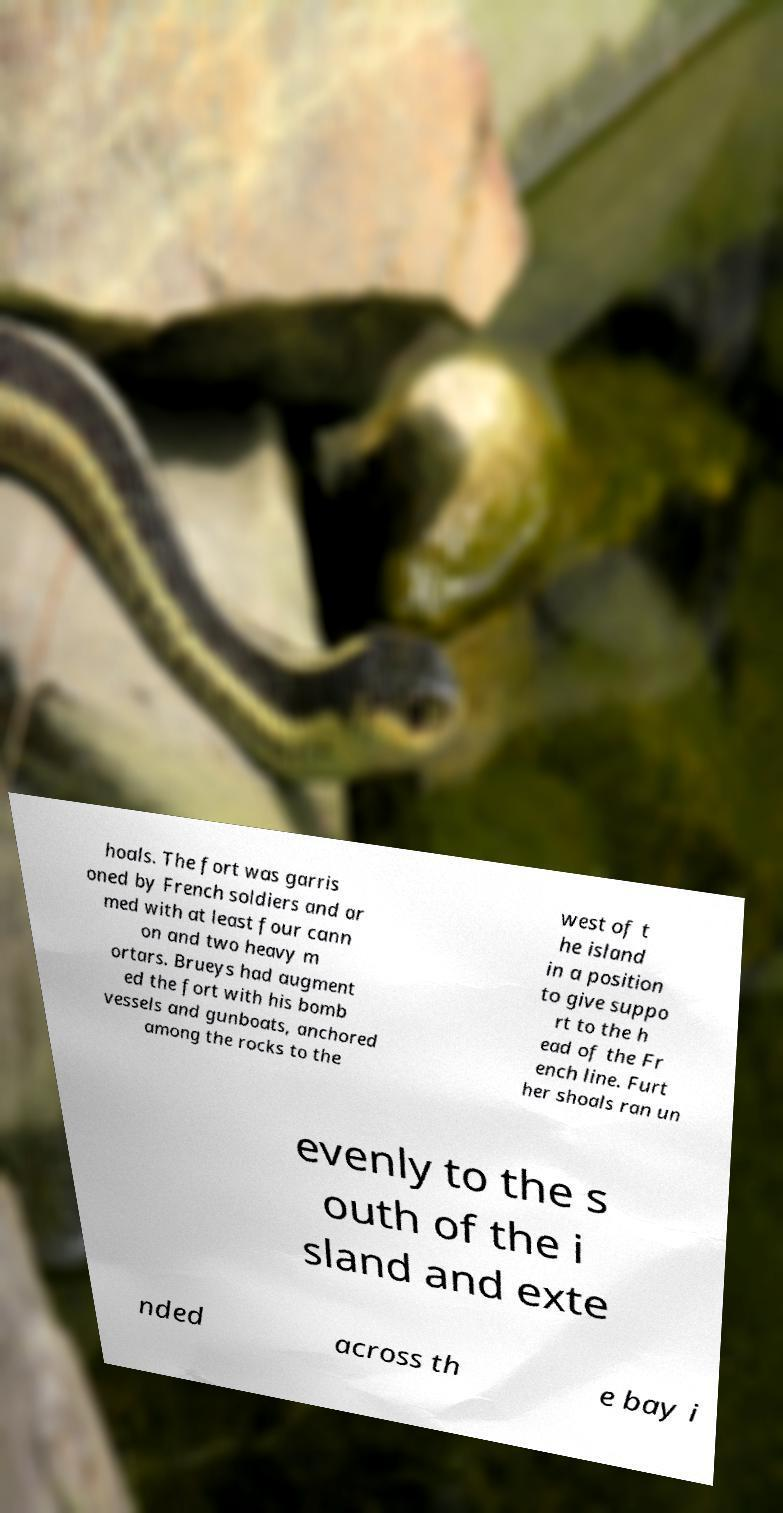There's text embedded in this image that I need extracted. Can you transcribe it verbatim? hoals. The fort was garris oned by French soldiers and ar med with at least four cann on and two heavy m ortars. Brueys had augment ed the fort with his bomb vessels and gunboats, anchored among the rocks to the west of t he island in a position to give suppo rt to the h ead of the Fr ench line. Furt her shoals ran un evenly to the s outh of the i sland and exte nded across th e bay i 